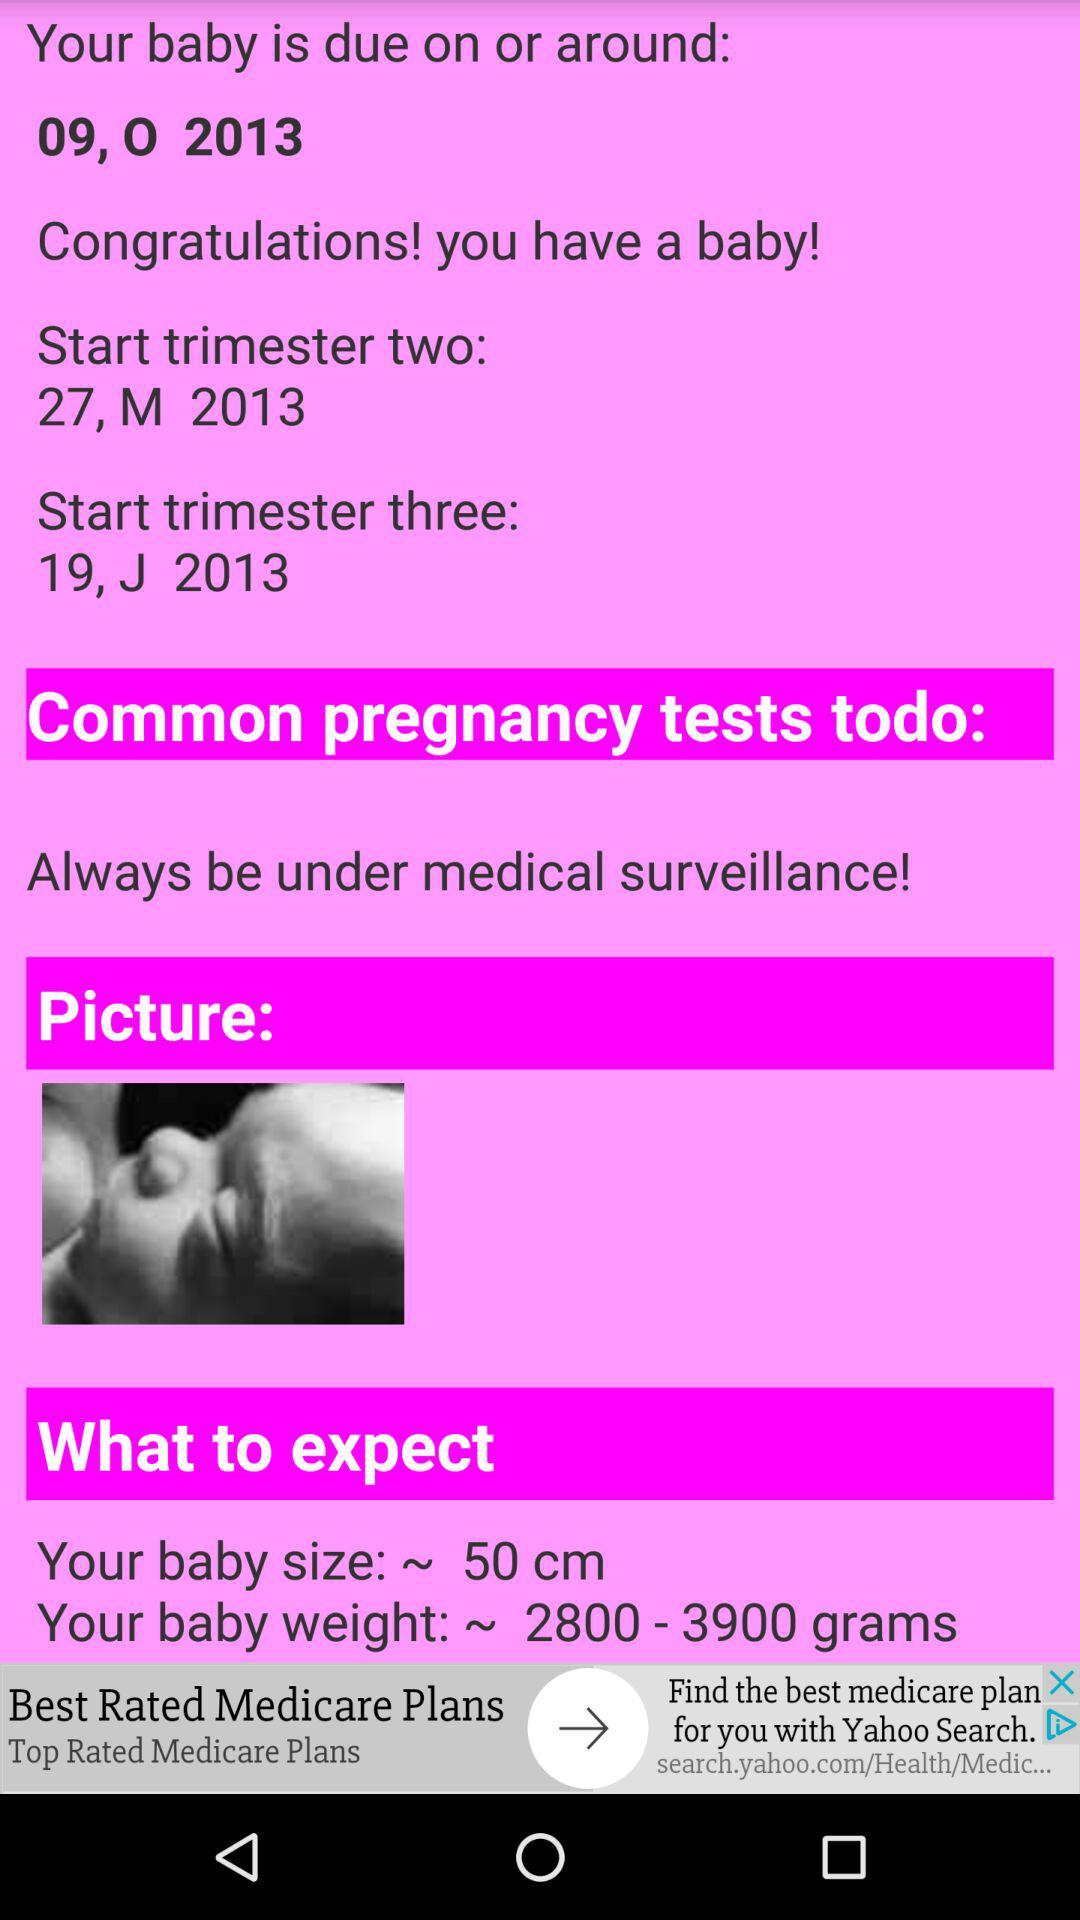What is the due date of the baby? The due date is October 9, 2013. 